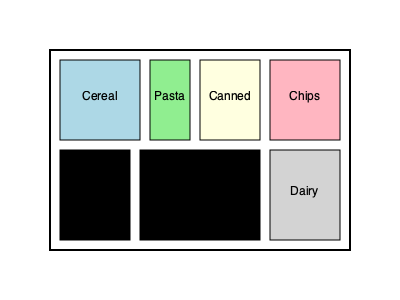Based on the shelf arrangement shown, which item category should be placed next to the bread to maximize space efficiency and minimize potential contamination? To answer this question, we need to consider several factors:

1. Space efficiency: We want to place items next to each other that have similar shapes or sizes to maximize shelf space usage.

2. Contamination prevention: We should avoid placing items that could potentially contaminate each other side by side.

3. Item characteristics:
   - Bread: Soft, prone to crushing, needs to be easily accessible
   - Cereal: Boxed, sturdy
   - Pasta: Small boxes or bags, relatively sturdy
   - Canned goods: Heavy, sturdy
   - Chips: Light, prone to crushing
   - Produce: Fresh, may need refrigeration
   - Dairy: Requires refrigeration, may have strong odors

4. Current arrangement: Bread is placed on the bottom shelf, taking up a rectangular space.

5. Available adjacent spaces: The produce section is currently next to the bread.

Considering these factors:

- Dairy should remain separate due to refrigeration needs and potential odor transfer.
- Chips are too fragile to be placed next to bread.
- Canned goods are too heavy and could potentially damage the bread.
- Cereal boxes are a good option as they are sturdy and have a similar shape to bread packaging.
- Pasta is also a viable option due to its similar packaging shape and low risk of contamination.

The most space-efficient and safe option would be to place either cereal or pasta next to the bread. Since cereal boxes are typically larger and more similar in size to bread packaging, they would be the optimal choice for maximizing space efficiency.
Answer: Cereal 